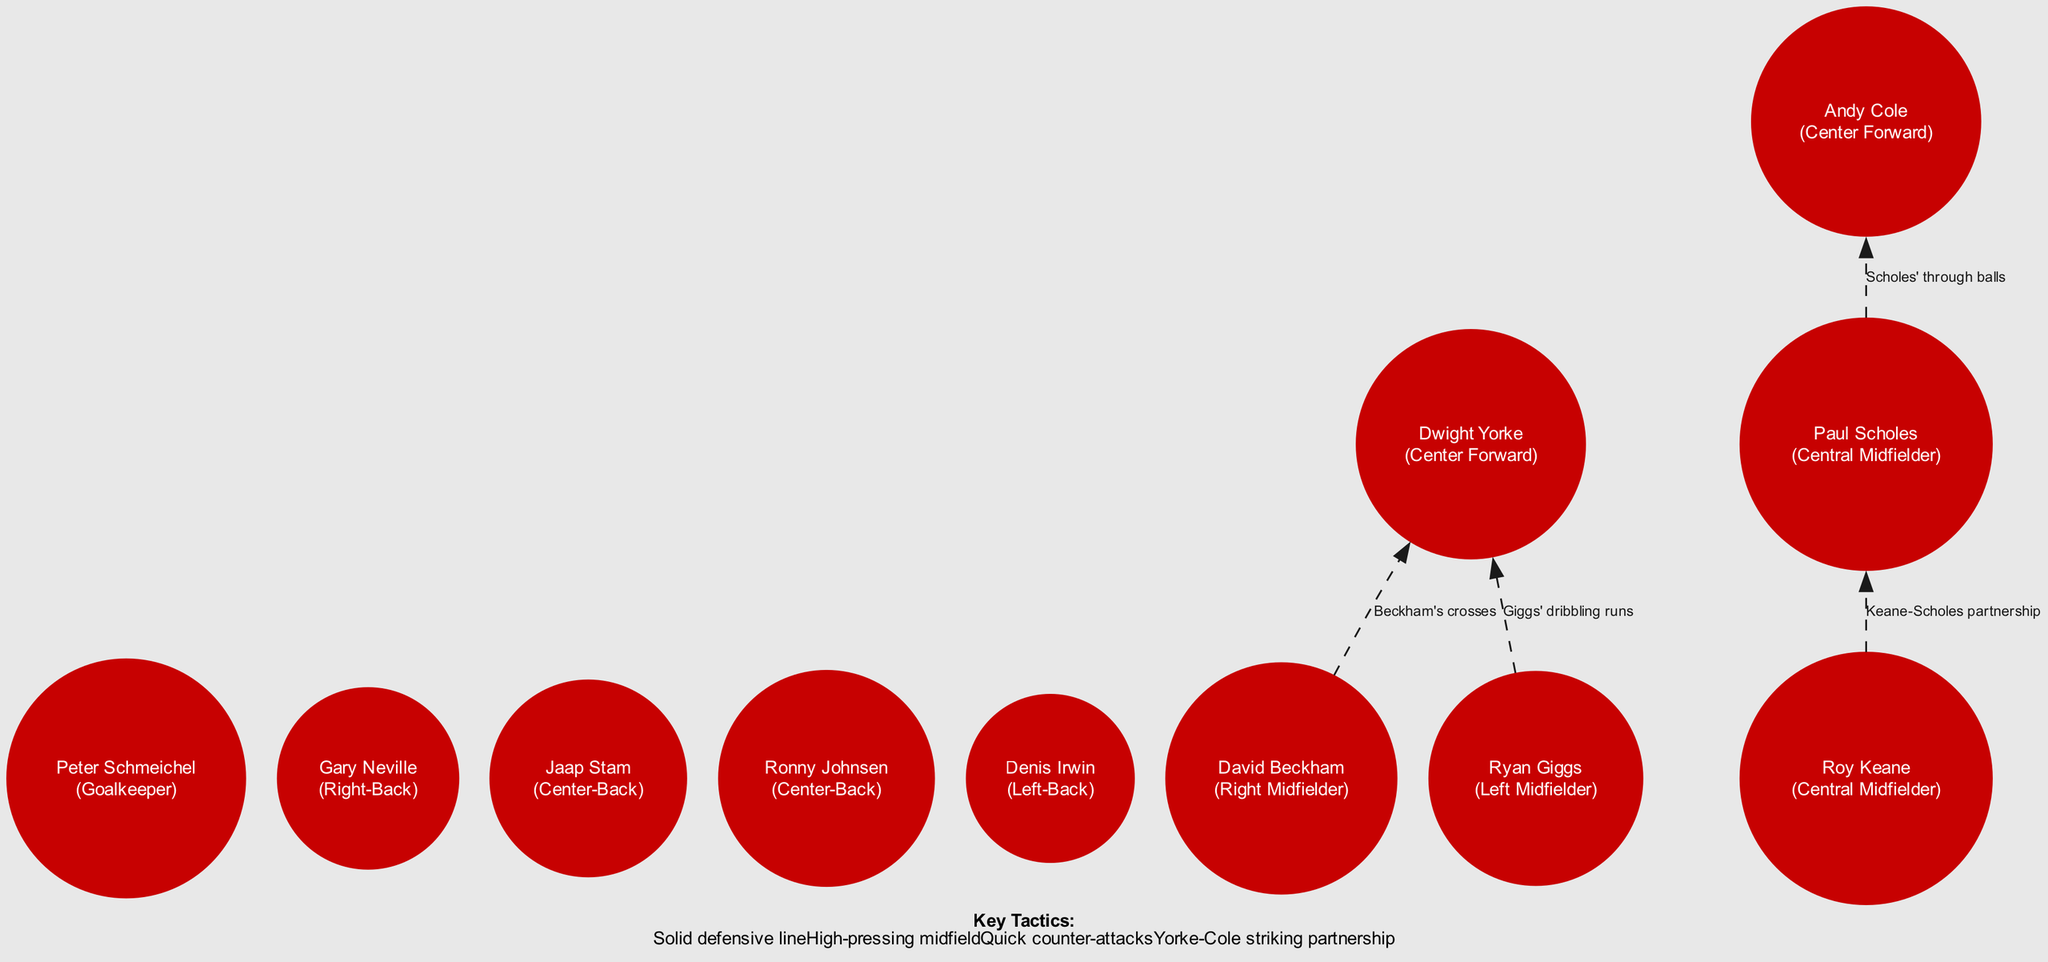What is the position of Peter Schmeichel? The diagram indicates that Peter Schmeichel is positioned as the Goalkeeper, which is a key node in any football formation. Thus, by identifying the label associated with his node, we can confirm his position.
Answer: Goalkeeper Who plays as the Right Midfielder? The diagram presents David Beckham as the Right Midfielder. By examining the nodes, we see that his label clearly states his position.
Answer: David Beckham How many players are in the defensive line? The diagram reveals that there are four players who comprise the defensive line: Gary Neville, Jaap Stam, Ronny Johnsen, and Denis Irwin. Counting those labeled as the Right-Back, Center-Backs, and Left-Back leads to this total.
Answer: 4 What movements are indicated for David Beckham? The edges show that from David Beckham's node, there are lines leading to the Center Forward (Dwight Yorke) with the label "Beckham's crosses". This indicates his role in delivering crosses from the right flank to the forwards.
Answer: Beckham's crosses What is the role of Keane and Scholes? The diagram reflects the partnership between Roy Keane and Paul Scholes, represented by the edge labeled "Keane-Scholes partnership". This relationship signifies their collaboration in midfield play, particularly in transitions.
Answer: Keane-Scholes partnership Which player is associated with dribbling runs? According to the diagram, Ryan Giggs is associated with dribbling runs as indicated by the edge moving from his node to Dwight Yorke's node, labeled as "Giggs' dribbling runs". This demonstrates his ability to carry the ball forward effectively.
Answer: Giggs' dribbling runs What is the tactical approach indicated in the notes? The notes section outlines key tactics including "Solid defensive line", "High-pressing midfield", and "Quick counter-attacks", suggesting a strategic emphasis on defensiveness and rapid transitions while attacking.
Answer: Solid defensive line, High-pressing midfield, Quick counter-attacks Which players form the striking partnership? The diagram points out that the striking partnership consists of Dwight Yorke and Andy Cole, identified in the nodes as Center Forwards. Their positioning indicates they work closely together in attacking plays.
Answer: Yorke-Cole striking partnership 